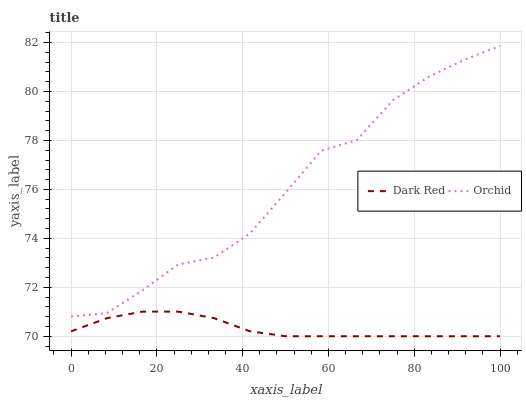Does Dark Red have the minimum area under the curve?
Answer yes or no. Yes. Does Orchid have the maximum area under the curve?
Answer yes or no. Yes. Does Orchid have the minimum area under the curve?
Answer yes or no. No. Is Dark Red the smoothest?
Answer yes or no. Yes. Is Orchid the roughest?
Answer yes or no. Yes. Is Orchid the smoothest?
Answer yes or no. No. Does Dark Red have the lowest value?
Answer yes or no. Yes. Does Orchid have the lowest value?
Answer yes or no. No. Does Orchid have the highest value?
Answer yes or no. Yes. Is Dark Red less than Orchid?
Answer yes or no. Yes. Is Orchid greater than Dark Red?
Answer yes or no. Yes. Does Dark Red intersect Orchid?
Answer yes or no. No. 